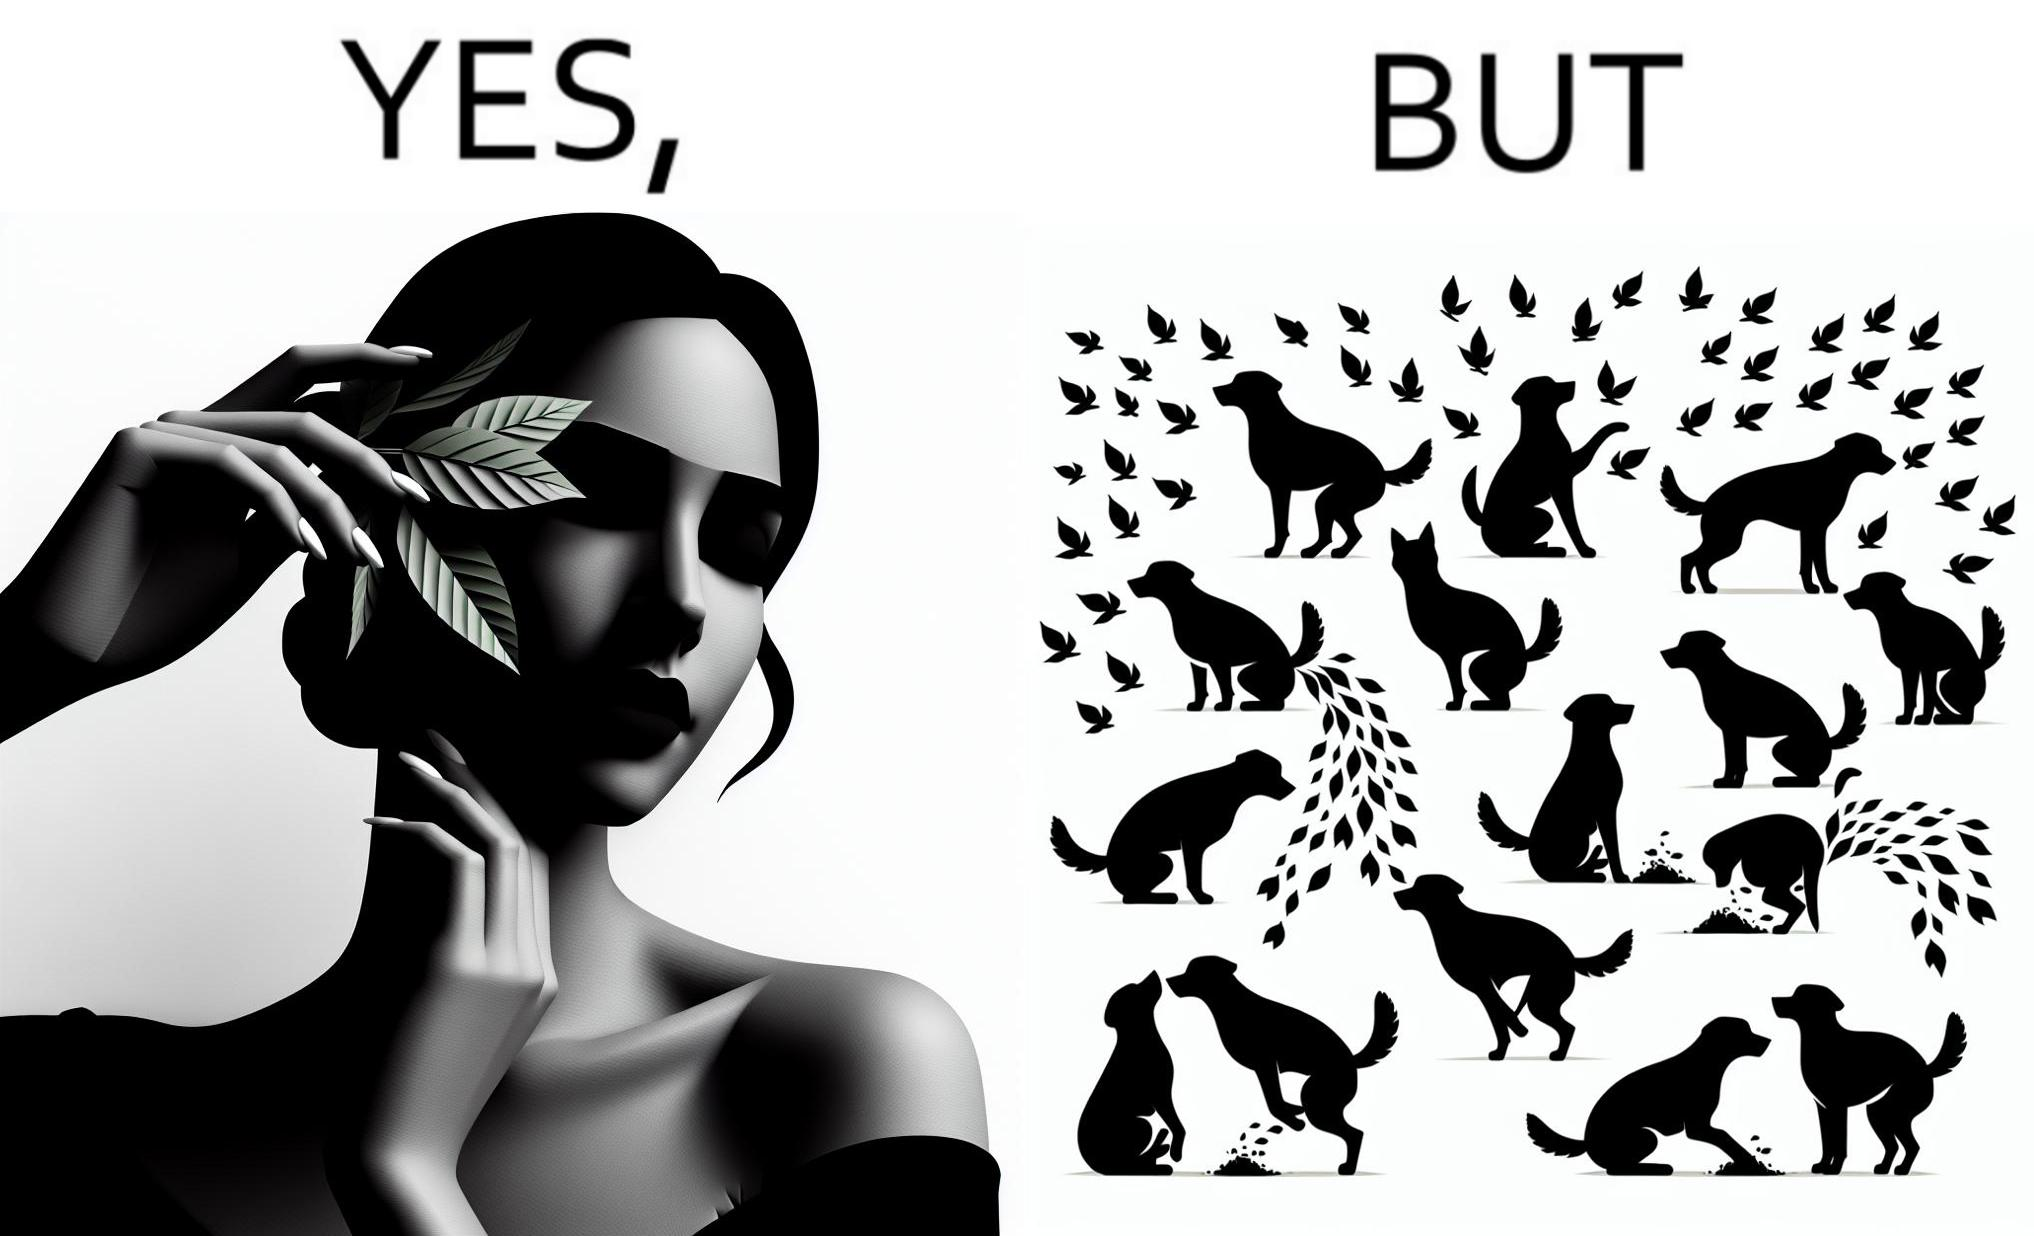Is this image satirical or non-satirical? Yes, this image is satirical. 